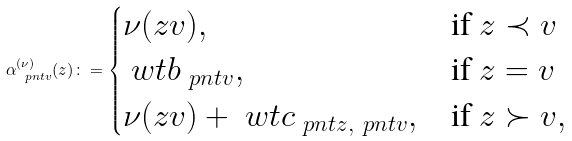Convert formula to latex. <formula><loc_0><loc_0><loc_500><loc_500>\alpha _ { \ p n t { v } } ^ { ( \nu ) } ( z ) \colon = \begin{cases} \nu ( z v ) , & \text {if $z \prec v$} \\ \ w t { b } _ { \ p n t { v } } , & \text {if $z = v$} \\ \nu ( z v ) + \ w t { c } _ { \ p n t { z } , \ p n t { v } } , & \text {if $z \succ v$} , \end{cases}</formula> 